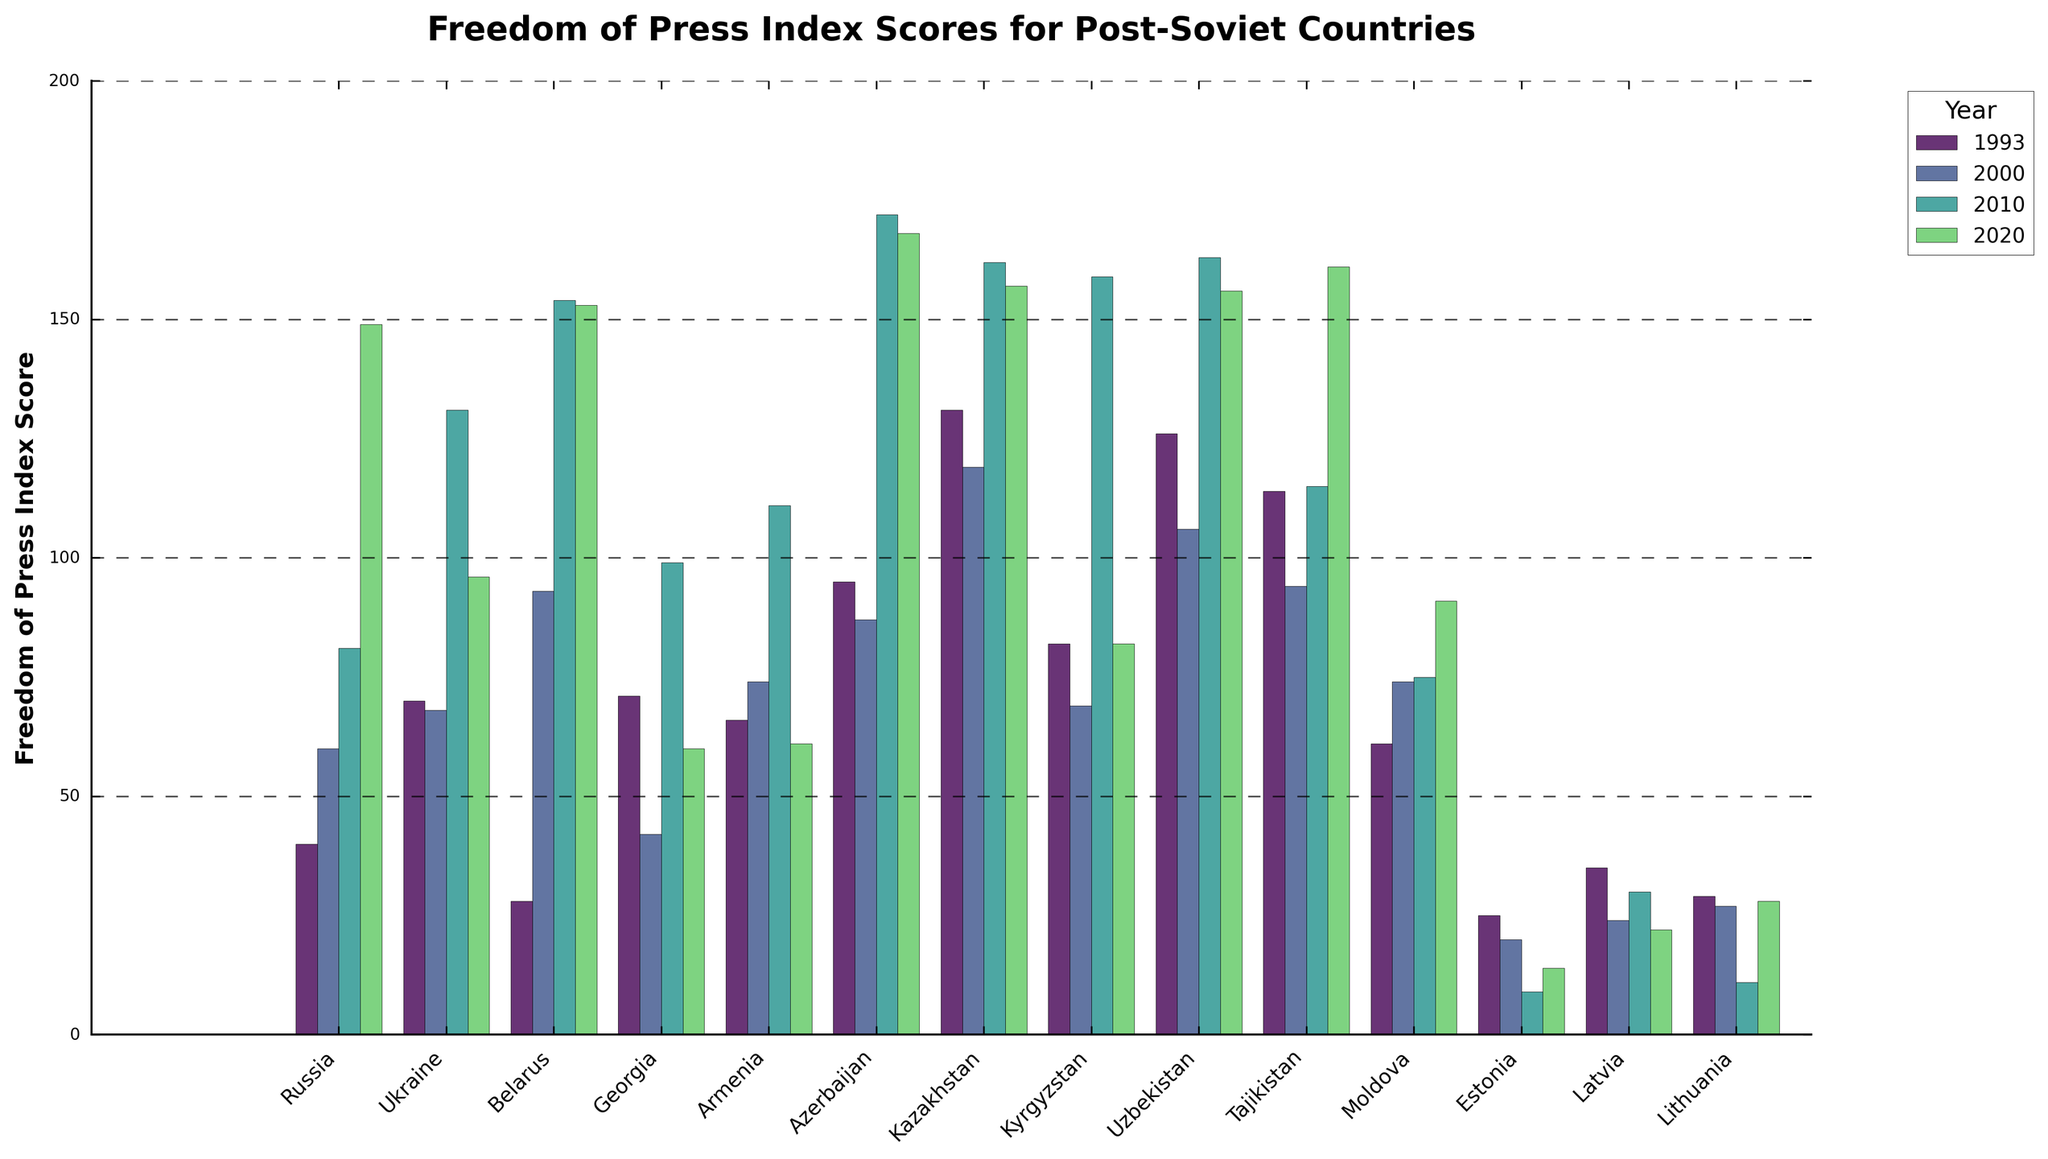Which post-Soviet country had the best Freedom of Press Index score in 2020? Look at the bar heights for 2020, the highest bar represents the worst score while the shortest bar represents the best score. Estonia has the shortest bar for 2020.
Answer: Estonia Which country had the most significant improvement in Freedom of Press Index scores between 1993 and 2020? Calculate the difference in scores between 1993 and 2020 for each country, then identify the country with the largest positive difference (decrease in score means improvement). Georgia had the largest improvement, from 71 to 60.
Answer: Georgia Which country experienced the largest decline in Freedom of Press Index between 1993 and 2020? Calculate the difference in scores between 1993 and 2020 for each country and identify the largest negative difference (increase in score means decline). Russia experienced the largest decline, from 40 to 149.
Answer: Russia What is the average Freedom of Press Index score for Lithuania across all the years presented? Sum the scores for Lithuania from 1993, 2000, 2010, and 2020, then divide by the number of years (4). (29 + 27 + 11 + 28) / 4 = 23.75
Answer: 23.75 Which country had a relatively consistent Freedom of Press score between 2000 and 2020? Look for countries where the bar heights for 2000 and 2020 show minimal changes. Latvia shows minimal change, with scores of 24 in 2000 and 22 in 2020.
Answer: Latvia Which year had the highest overall Freedom of Press Index scores across all countries? Add up the scores for all countries for each year presented, then compare totals. The year 2020 had the highest total score (poor press freedom).
Answer: 2020 For 2020, which country had nearly identical Freedom of Press Index scores as Belarus? Compare the bar heights visually for 2020, find the one closest to Belarus’s 153. Azerbaijan has a score very close to Belarus at 168.
Answer: Azerbaijan Which country showed the highest score improvement between 2000 and 2020 among those whose score was worse in 2010 than in 2000? Identify countries where the score worsened from 2000 to 2010, then calculate score differences from 2000 to 2020 and select the highest improvement. Kyrgyzstan worsened from 69 in 2000 to 159 in 2010 and improved to 82 in 2020.
Answer: Kyrgyzstan Which country had the best score in 2000 and how much better was it compared to the worst score that year? Identify the lowest score for 2000 and the highest score for 2000, then find the difference. Estonia had the best score at 20, and Kazakhstan had the worst at 119 with a difference of 119 - 20 = 99.
Answer: 99 